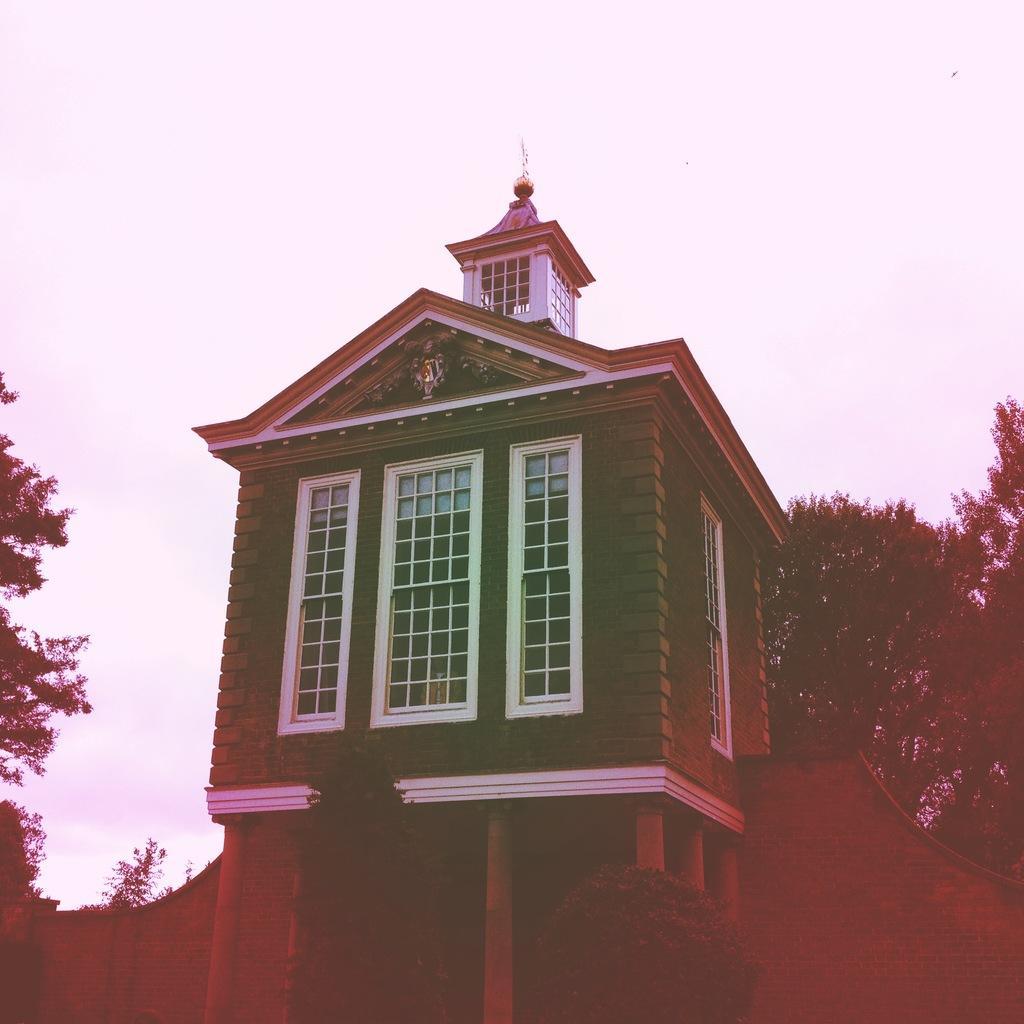In one or two sentences, can you explain what this image depicts? In this image I can see a building. At the back there is a wall. On the right and left sides of the image I can see the trees. At the top of the image I can see the sky. 